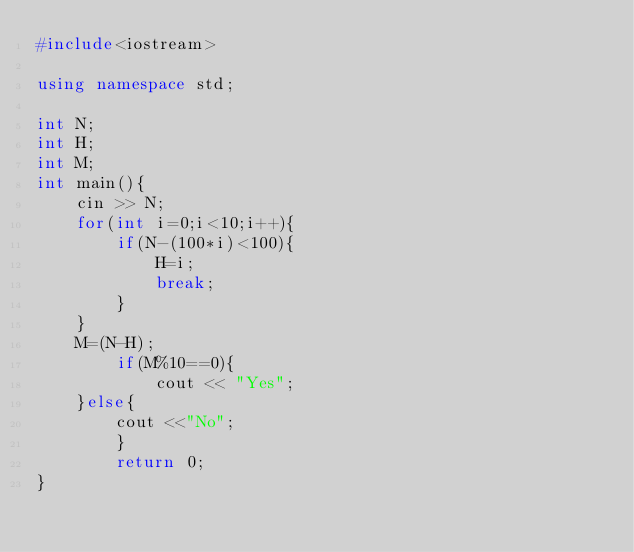<code> <loc_0><loc_0><loc_500><loc_500><_C++_>#include<iostream>

using namespace std;

int N;
int H;
int M;
int main(){
	cin >> N;
	for(int i=0;i<10;i++){
		if(N-(100*i)<100){
			H=i;
			break;
		}
	}
	M=(N-H);
		if(M%10==0){
			cout << "Yes";
	}else{
		cout <<"No";
		}
		return 0;
}</code> 